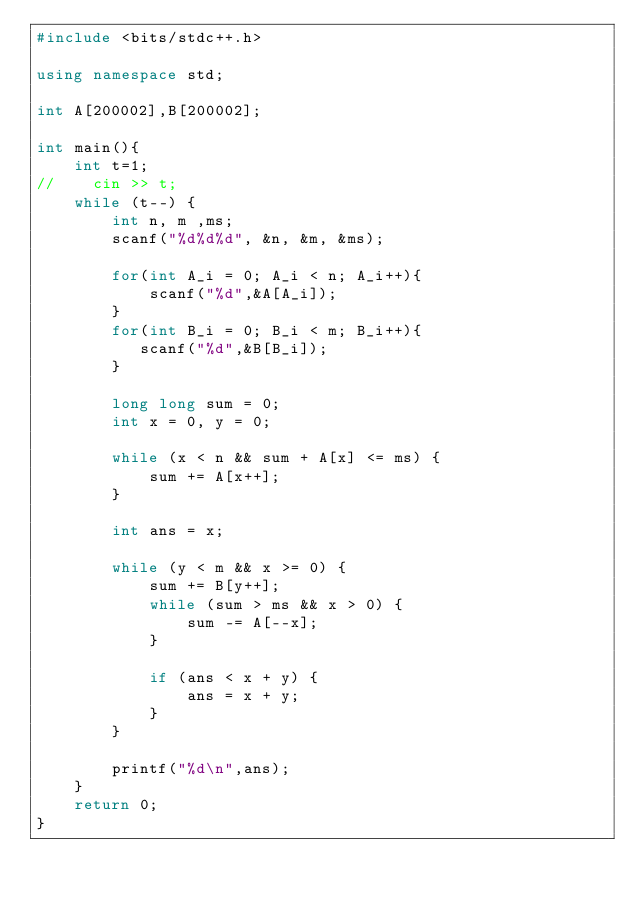<code> <loc_0><loc_0><loc_500><loc_500><_C++_>#include <bits/stdc++.h>

using namespace std;

int A[200002],B[200002];

int main(){
    int t=1;
//    cin >> t;
    while (t--) {
        int n, m ,ms;
        scanf("%d%d%d", &n, &m, &ms);
 
        for(int A_i = 0; A_i < n; A_i++){
            scanf("%d",&A[A_i]);
        }
        for(int B_i = 0; B_i < m; B_i++){
           scanf("%d",&B[B_i]);
        }

        long long sum = 0;
        int x = 0, y = 0;

        while (x < n && sum + A[x] <= ms) {
            sum += A[x++];
        }

        int ans = x;

        while (y < m && x >= 0) {
            sum += B[y++];
            while (sum > ms && x > 0) {
                sum -= A[--x];
            }

            if (ans < x + y) {
                ans = x + y;
            }
        }

        printf("%d\n",ans);
    }
    return 0;
}
</code> 